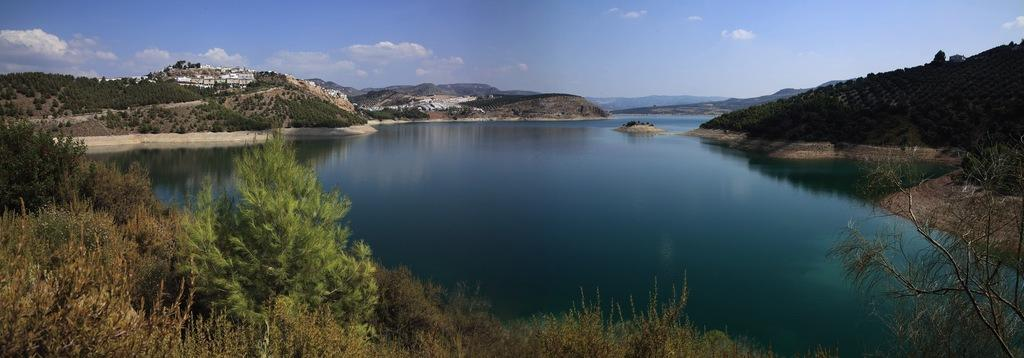What is the primary element in the center of the image? There is sky in the center of the image. What can be seen in the sky? Clouds are visible in the image. What type of natural features are present in the image? Trees, hills, and water are visible in the image. What type of man-made structures are present in the image? Buildings are present in the image. What type of vegetation is visible in the image? Plants and grass are visible in the image. What type of engine can be seen powering the table in the image? There is no table or engine present in the image. 